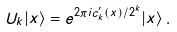<formula> <loc_0><loc_0><loc_500><loc_500>U _ { k } | x \rangle = e ^ { 2 \pi i c ^ { \prime } _ { k } ( x ) / 2 ^ { k } } | x \rangle \, .</formula> 